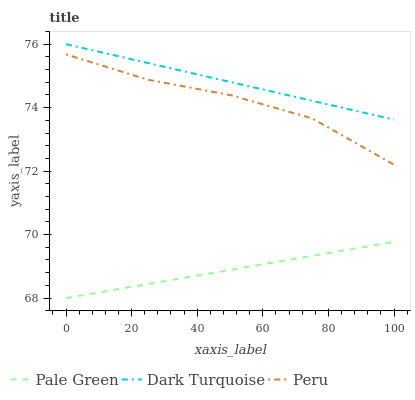Does Pale Green have the minimum area under the curve?
Answer yes or no. Yes. Does Dark Turquoise have the maximum area under the curve?
Answer yes or no. Yes. Does Peru have the minimum area under the curve?
Answer yes or no. No. Does Peru have the maximum area under the curve?
Answer yes or no. No. Is Dark Turquoise the smoothest?
Answer yes or no. Yes. Is Peru the roughest?
Answer yes or no. Yes. Is Pale Green the smoothest?
Answer yes or no. No. Is Pale Green the roughest?
Answer yes or no. No. Does Pale Green have the lowest value?
Answer yes or no. Yes. Does Peru have the lowest value?
Answer yes or no. No. Does Dark Turquoise have the highest value?
Answer yes or no. Yes. Does Peru have the highest value?
Answer yes or no. No. Is Peru less than Dark Turquoise?
Answer yes or no. Yes. Is Dark Turquoise greater than Pale Green?
Answer yes or no. Yes. Does Peru intersect Dark Turquoise?
Answer yes or no. No. 